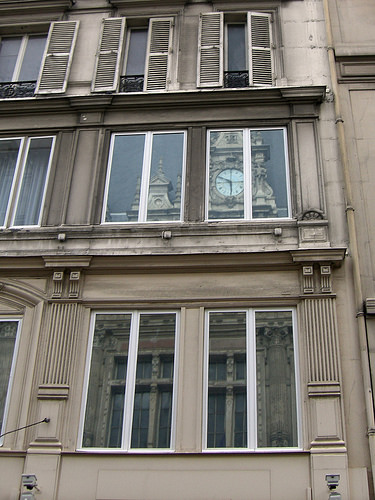<image>
Can you confirm if the clock is on the window? No. The clock is not positioned on the window. They may be near each other, but the clock is not supported by or resting on top of the window. Where is the clock in relation to the wall? Is it in front of the wall? No. The clock is not in front of the wall. The spatial positioning shows a different relationship between these objects. 